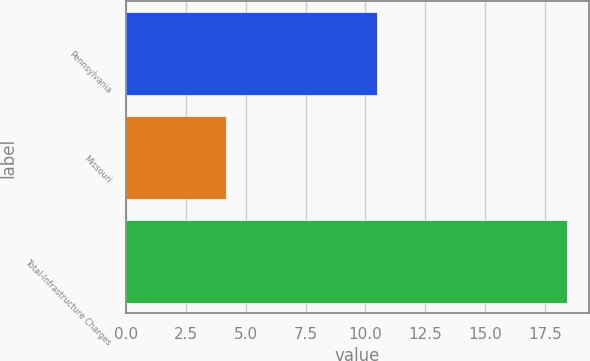Convert chart to OTSL. <chart><loc_0><loc_0><loc_500><loc_500><bar_chart><fcel>Pennsylvania<fcel>Missouri<fcel>Total-Infrastructure Charges<nl><fcel>10.5<fcel>4.2<fcel>18.4<nl></chart> 